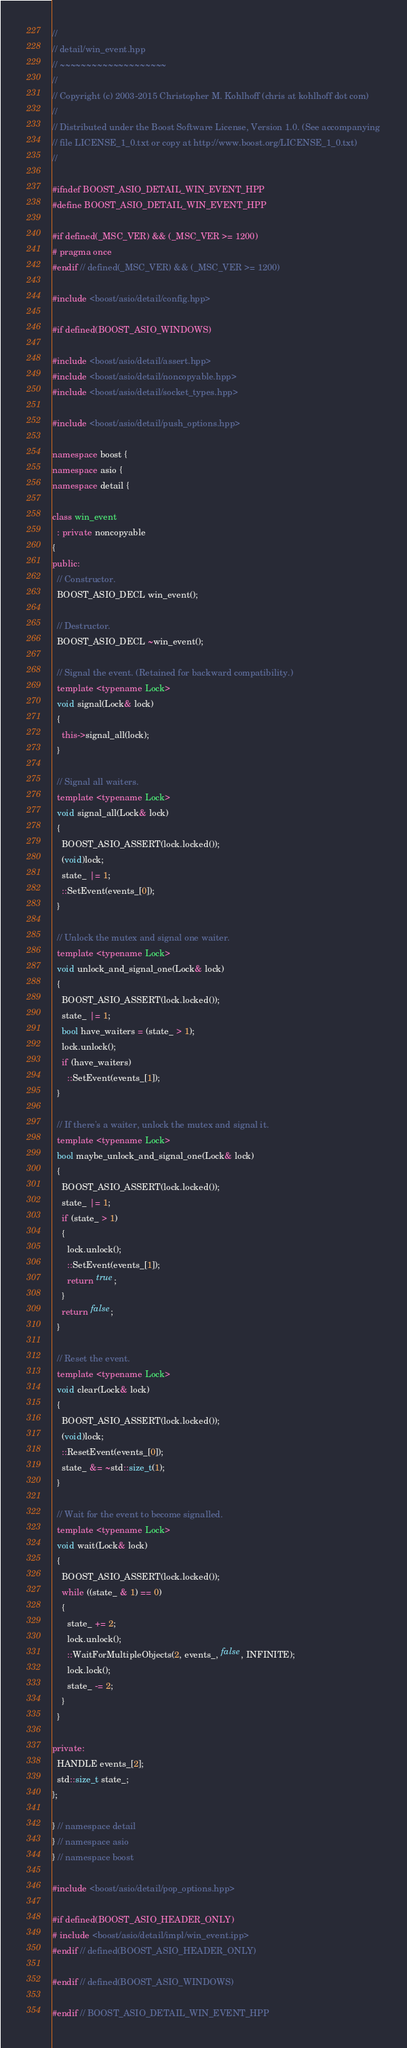<code> <loc_0><loc_0><loc_500><loc_500><_C++_>//
// detail/win_event.hpp
// ~~~~~~~~~~~~~~~~~~~~
//
// Copyright (c) 2003-2015 Christopher M. Kohlhoff (chris at kohlhoff dot com)
//
// Distributed under the Boost Software License, Version 1.0. (See accompanying
// file LICENSE_1_0.txt or copy at http://www.boost.org/LICENSE_1_0.txt)
//

#ifndef BOOST_ASIO_DETAIL_WIN_EVENT_HPP
#define BOOST_ASIO_DETAIL_WIN_EVENT_HPP

#if defined(_MSC_VER) && (_MSC_VER >= 1200)
# pragma once
#endif // defined(_MSC_VER) && (_MSC_VER >= 1200)

#include <boost/asio/detail/config.hpp>

#if defined(BOOST_ASIO_WINDOWS)

#include <boost/asio/detail/assert.hpp>
#include <boost/asio/detail/noncopyable.hpp>
#include <boost/asio/detail/socket_types.hpp>

#include <boost/asio/detail/push_options.hpp>

namespace boost {
namespace asio {
namespace detail {

class win_event
  : private noncopyable
{
public:
  // Constructor.
  BOOST_ASIO_DECL win_event();

  // Destructor.
  BOOST_ASIO_DECL ~win_event();

  // Signal the event. (Retained for backward compatibility.)
  template <typename Lock>
  void signal(Lock& lock)
  {
    this->signal_all(lock);
  }

  // Signal all waiters.
  template <typename Lock>
  void signal_all(Lock& lock)
  {
    BOOST_ASIO_ASSERT(lock.locked());
    (void)lock;
    state_ |= 1;
    ::SetEvent(events_[0]);
  }

  // Unlock the mutex and signal one waiter.
  template <typename Lock>
  void unlock_and_signal_one(Lock& lock)
  {
    BOOST_ASIO_ASSERT(lock.locked());
    state_ |= 1;
    bool have_waiters = (state_ > 1);
    lock.unlock();
    if (have_waiters)
      ::SetEvent(events_[1]);
  }

  // If there's a waiter, unlock the mutex and signal it.
  template <typename Lock>
  bool maybe_unlock_and_signal_one(Lock& lock)
  {
    BOOST_ASIO_ASSERT(lock.locked());
    state_ |= 1;
    if (state_ > 1)
    {
      lock.unlock();
      ::SetEvent(events_[1]);
      return true;
    }
    return false;
  }

  // Reset the event.
  template <typename Lock>
  void clear(Lock& lock)
  {
    BOOST_ASIO_ASSERT(lock.locked());
    (void)lock;
    ::ResetEvent(events_[0]);
    state_ &= ~std::size_t(1);
  }

  // Wait for the event to become signalled.
  template <typename Lock>
  void wait(Lock& lock)
  {
    BOOST_ASIO_ASSERT(lock.locked());
    while ((state_ & 1) == 0)
    {
      state_ += 2;
      lock.unlock();
      ::WaitForMultipleObjects(2, events_, false, INFINITE);
      lock.lock();
      state_ -= 2;
    }
  }

private:
  HANDLE events_[2];
  std::size_t state_;
};

} // namespace detail
} // namespace asio
} // namespace boost

#include <boost/asio/detail/pop_options.hpp>

#if defined(BOOST_ASIO_HEADER_ONLY)
# include <boost/asio/detail/impl/win_event.ipp>
#endif // defined(BOOST_ASIO_HEADER_ONLY)

#endif // defined(BOOST_ASIO_WINDOWS)

#endif // BOOST_ASIO_DETAIL_WIN_EVENT_HPP
</code> 